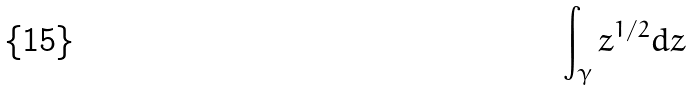<formula> <loc_0><loc_0><loc_500><loc_500>\int _ { \gamma } z ^ { 1 / 2 } d z</formula> 